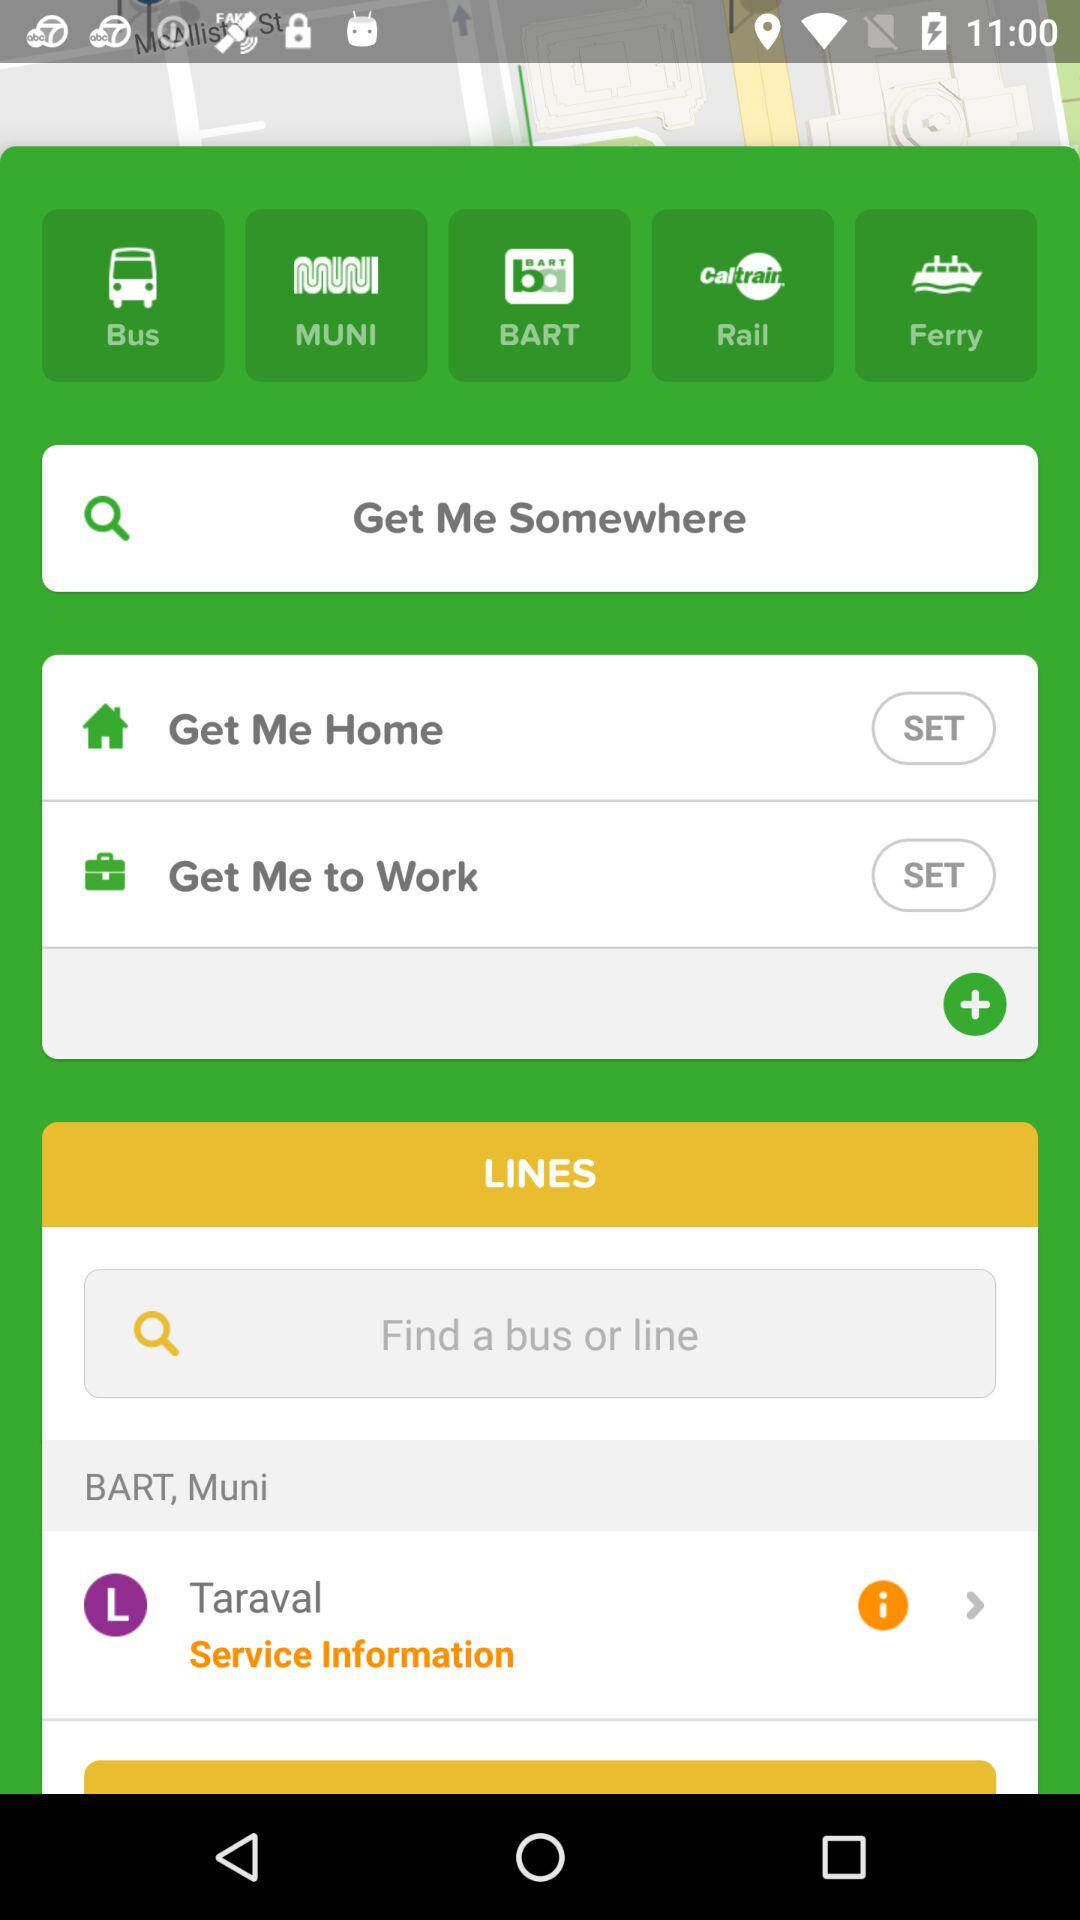How many text inputs are on the screen?
Answer the question using a single word or phrase. 2 